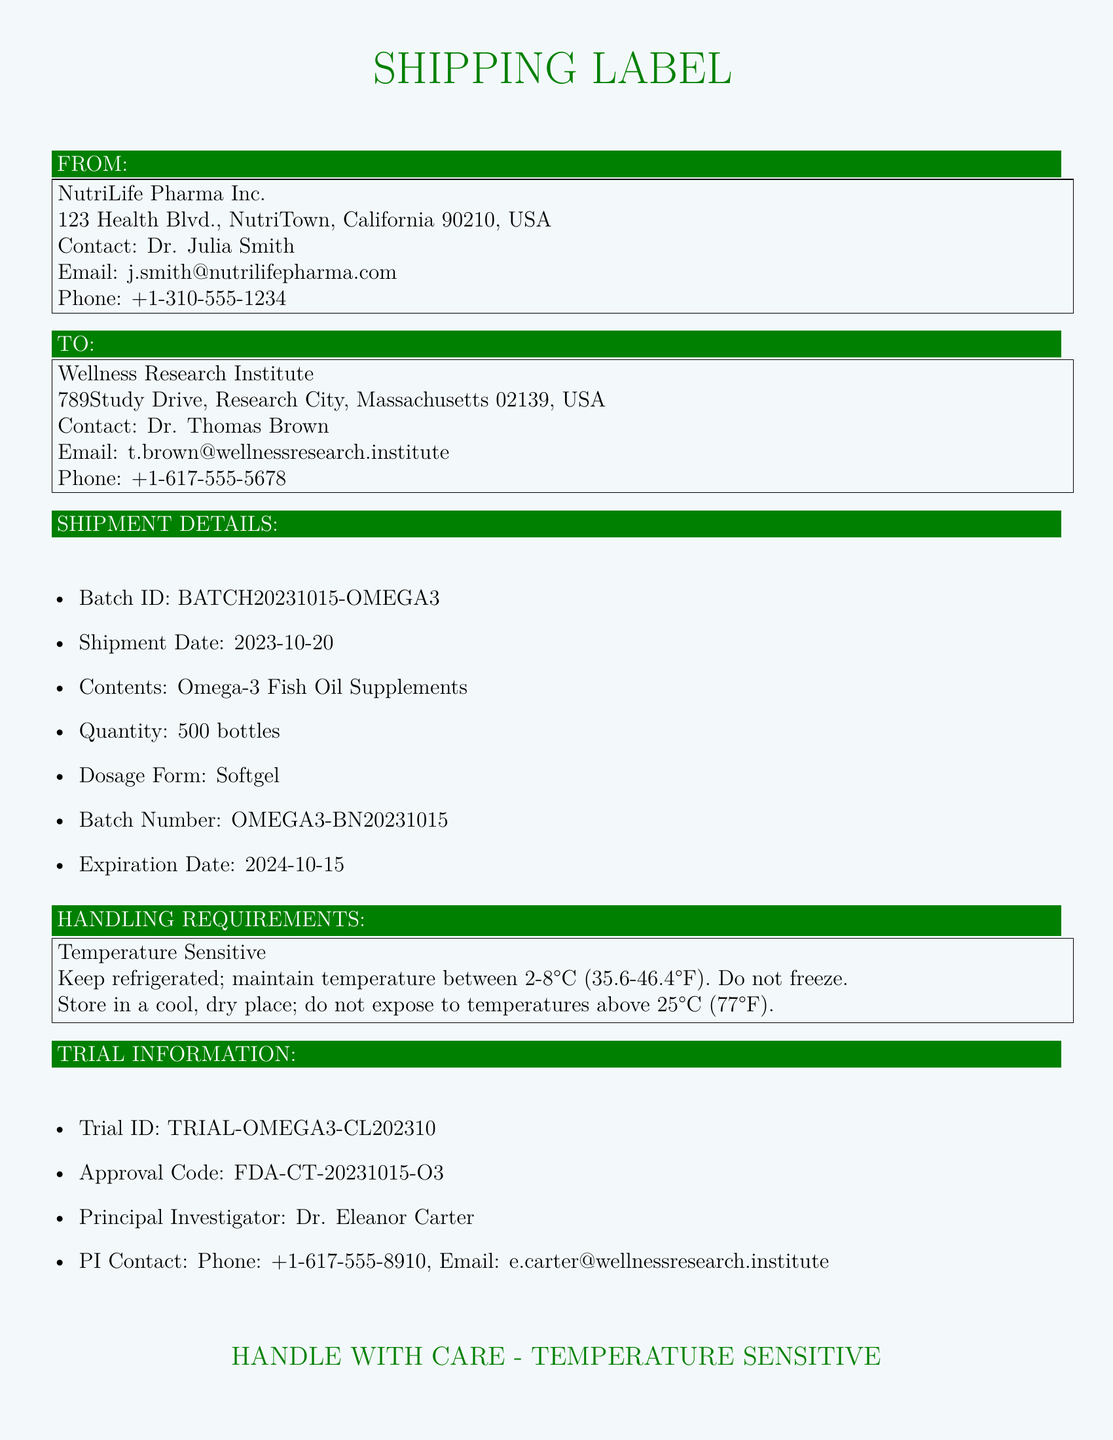What is the Batch ID? The Batch ID is specified in the shipment details section of the label, which is BATCH20231015-OMEGA3.
Answer: BATCH20231015-OMEGA3 What is the shipment date? The shipment date is mentioned under the shipment details section, which states 2023-10-20.
Answer: 2023-10-20 How many bottles are included in the shipment? The quantity of bottles is explicitly listed in the shipment details, which shows 500 bottles.
Answer: 500 bottles What is the expiration date of the supplements? The expiration date is given in the shipment details, which states 2024-10-15.
Answer: 2024-10-15 What is the Trial ID? The Trial ID is listed in the trial information section, which is TRIAL-OMEGA3-CL202310.
Answer: TRIAL-OMEGA3-CL202310 Who is the Principal Investigator? The Principal Investigator is mentioned in the trial information section, Dr. Eleanor Carter.
Answer: Dr. Eleanor Carter What temperature should the supplements be stored at? The handling requirements specify keeping the temperature between 2-8°C (35.6-46.4°F).
Answer: 2-8°C (35.6-46.4°F) What is the approval code for the trial? The approval code is found in the trial information section, which is FDA-CT-20231015-O3.
Answer: FDA-CT-20231015-O3 What is the contact email for Dr. Thomas Brown? Dr. Thomas Brown's contact email is provided in the 'TO' section which is t.brown@wellnessresearch.institute.
Answer: t.brown@wellnessresearch.institute 